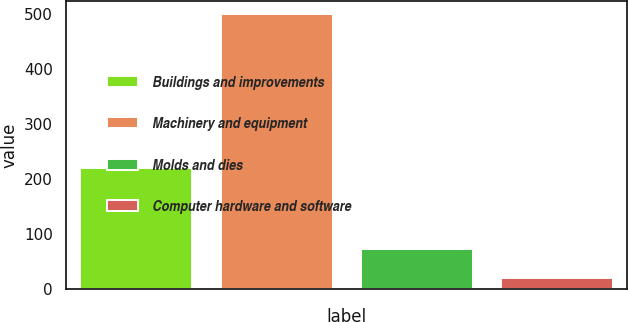Convert chart to OTSL. <chart><loc_0><loc_0><loc_500><loc_500><bar_chart><fcel>Buildings and improvements<fcel>Machinery and equipment<fcel>Molds and dies<fcel>Computer hardware and software<nl><fcel>220.7<fcel>499.6<fcel>73.1<fcel>20.1<nl></chart> 